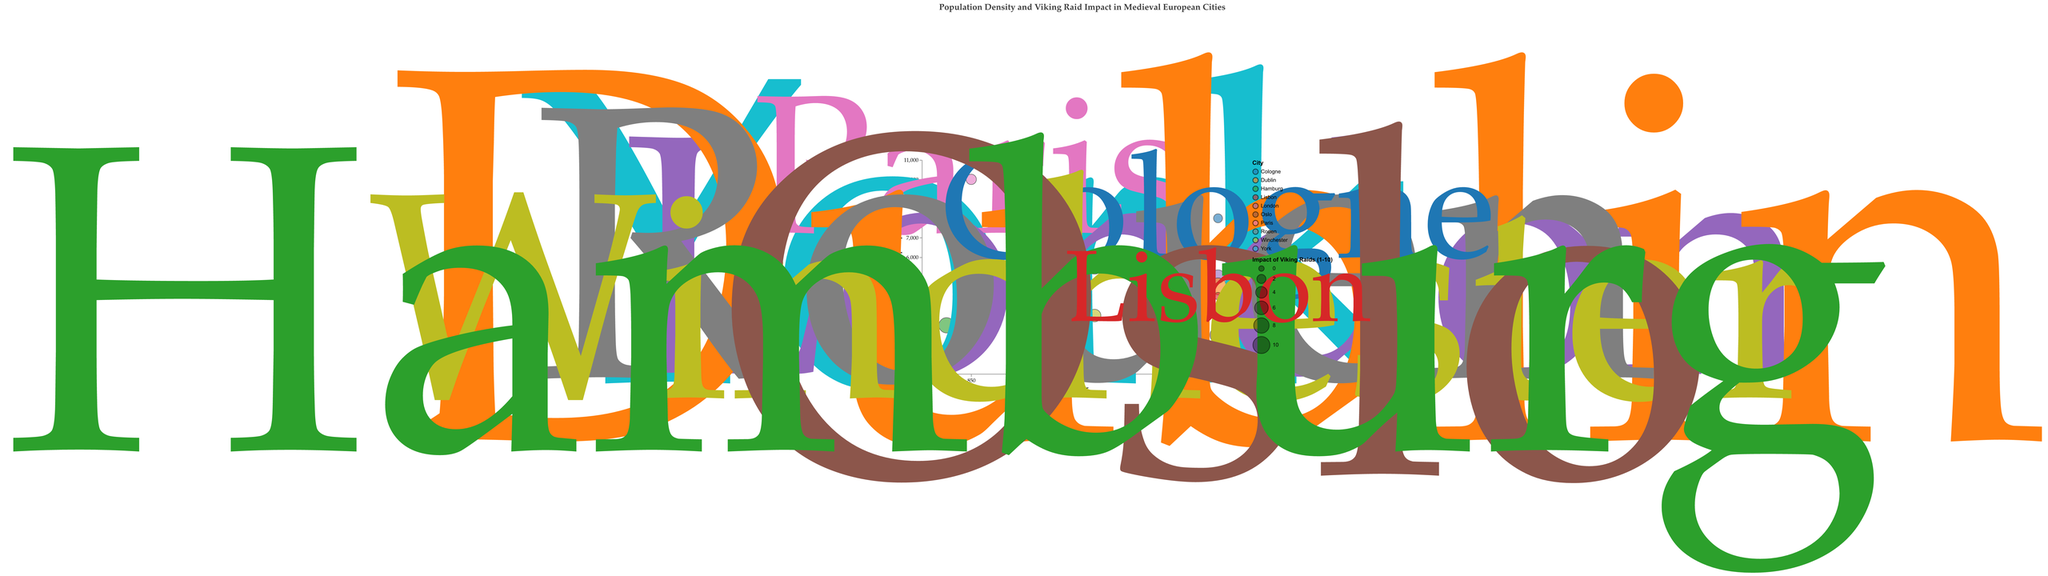What is the title of the figure? The title can be found at the top of the figure and is usually clearly labeled. It helps provide context and understanding for what the figure represents.
Answer: "Population Density and Viking Raid Impact in Medieval European Cities" Which city had the highest population density in the year 850? To determine this, look at the cities listed for the year 850 and compare their population density values. Paris in 850 is shown to have the highest population density among the given options.
Answer: Paris Which city experienced the highest impact of Viking raids? Look for the bubble with the largest size as the size correlates with the Impact of Viking Raids. Dublin has the largest bubble indicating it experienced the highest impact.
Answer: Dublin Which city had the lowest population density and in what year? Examine the bubbles with the y-axis value for population density, and identify the one with the lowest position. Oslo, with a population density of 2000 per sq km in the year 900, is the lowest.
Answer: Oslo in 900 Compare the population density and impact of Viking raids between Paris and York in 850. Which city had a higher population density and which had a higher impact of Viking raids? Paris and York both have data for 850. Paris had a population density of 10,000 per sq km, higher than York’s 6,000 per sq km. However, York had a higher impact of Viking raids with a value of 8 compared to Paris' 3.
Answer: Paris had a higher population density; York had a higher impact of Viking raids Which city from the list had the least impact of Viking raids and what was its population density? Identify the smallest bubble indicating least impact, which is Lisbon with an impact of 1. The population density of Lisbon in 900 was 4,000 per sq km.
Answer: Lisbon with a population density of 4000 per sq km What is the average population density of all the cities mentioned in the chart? Sum the population densities of all cities and divide by the number of cities. Calculation: (6000 + 10000 + 5000 + 4500 + 5500 + 8000 + 3000 + 2000 + 2500 + 4000) / 10 = 49,500 / 10 = 4,950 per sq km
Answer: 4950 per sq km What is the population density range depicted in the figure? Look at the y-axis scale where population density values are plotted. The scale ranges from 0 to 11,000. Therefore, the range encompasses these values.
Answer: 0 to 11,000 per sq km Is there any city with a population density of exactly 5000 per sq km? If so, which city and year? Scan the population density values for 5000 per sq km. London in the year 900 matches this population density.
Answer: London in 900 Among the cities in different years, which year had the highest population density overall? Assess the population densities for each year listed. The highest numeric value for any year is from Paris in 850 with 10,000 per sq km.
Answer: The year 850 